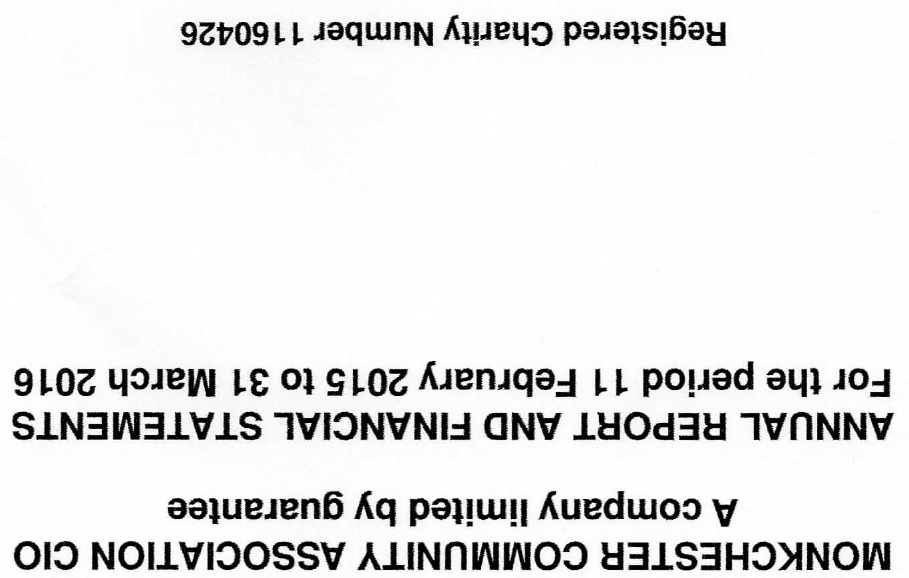What is the value for the charity_name?
Answer the question using a single word or phrase. Monkchester Community Association CIO 